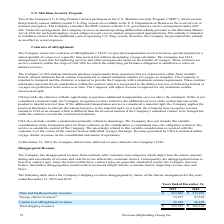According to Overseas Shipholding Group's financial document, Does the company believe that believe that further disaggregation would result in increased insight into the economic factors? the Company does not believe that further disaggregation would result in increased insight into the economic factors impacting revenue and cash flows.. The document states: "e contract types are generally standard in nature, the Company does not believe that further disaggregation would result in increased insight into the..." Also, can you calculate: What is the change in Time and bareboat charter revenues from Years Ended December 31, 2018 to 2019? Based on the calculation: 263,683-213,923, the result is 49760. This is based on the information: "Time and bareboat charter revenues $ 263,683 $ 213,923 Time and bareboat charter revenues $ 263,683 $ 213,923..." The key data points involved are: 213,923, 263,683. Also, can you calculate: What is the average Time and bareboat charter revenues for Years Ended December 31, 2018 to 2019? To answer this question, I need to perform calculations using the financial data. The calculation is: (263,683+213,923) / 2, which equals 238803. This is based on the information: "Time and bareboat charter revenues $ 263,683 $ 213,923 Time and bareboat charter revenues $ 263,683 $ 213,923..." The key data points involved are: 213,923, 263,683. Additionally, In which year was Voyage charter revenues less than 50,000? According to the financial document, 2019. The relevant text states: "2019 2018..." Also, What was the Time and bareboat charter revenues revenues in 2019 and 2018 respectively? The document shows two values: $263,683 and $213,923. From the document: "Time and bareboat charter revenues $ 263,683 $ 213,923 Time and bareboat charter revenues $ 263,683 $ 213,923..." Also, What was the Contracts of affreightment revenues in 2019 and 2018 respectively? The document shows two values: 58,589 and 68,698. From the document: "Contracts of affreightment revenues 58,589 68,698 Contracts of affreightment revenues 58,589 68,698..." 